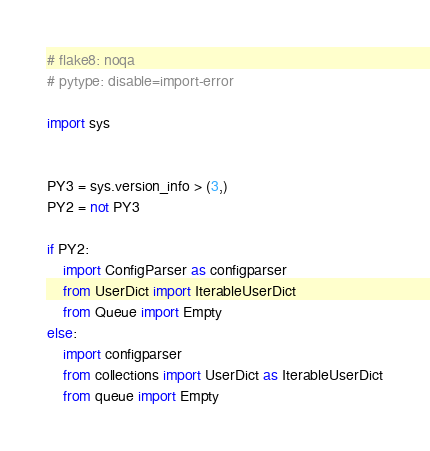<code> <loc_0><loc_0><loc_500><loc_500><_Python_># flake8: noqa
# pytype: disable=import-error

import sys


PY3 = sys.version_info > (3,)
PY2 = not PY3

if PY2:
    import ConfigParser as configparser
    from UserDict import IterableUserDict
    from Queue import Empty
else:
    import configparser
    from collections import UserDict as IterableUserDict
    from queue import Empty
</code> 